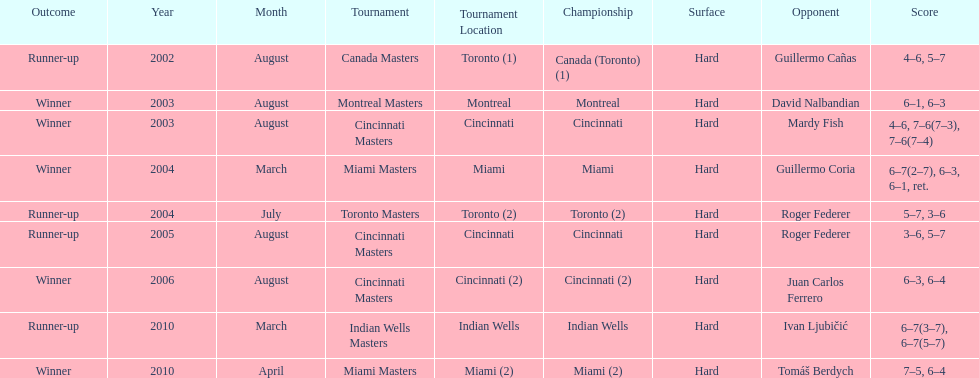What is his highest number of consecutive wins? 3. 